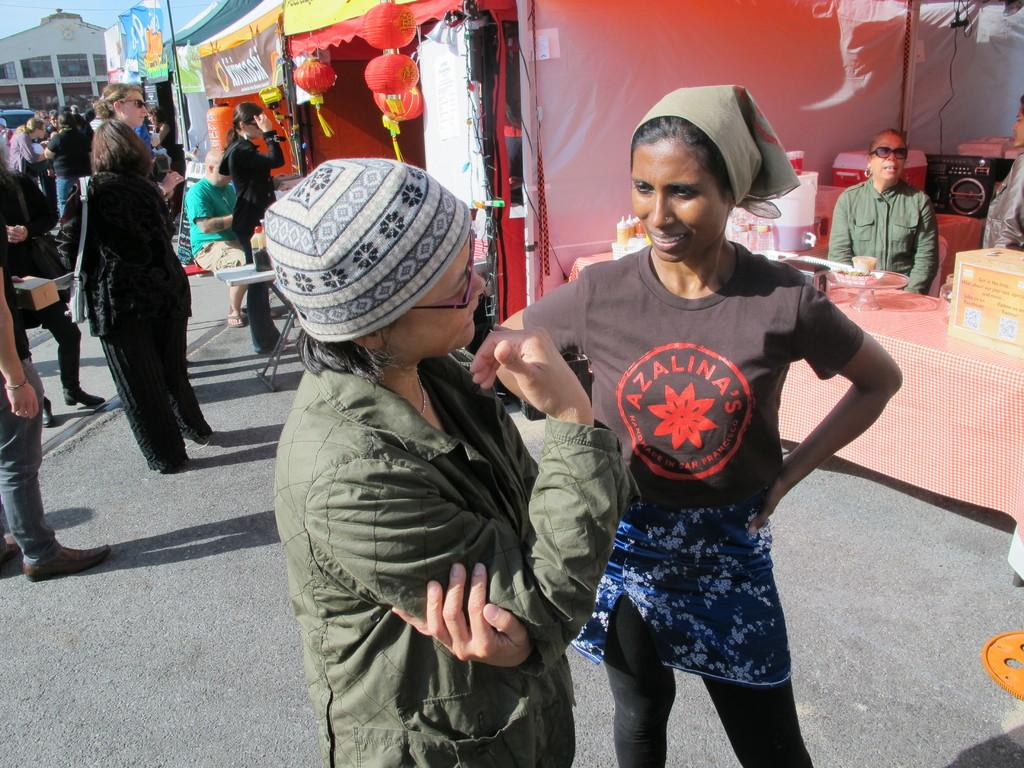What are the people in the image doing? The people in the image are standing on the ground. What type of furniture can be seen in the image? There are tables in the image. What decorative items are present in the image? Banners and lanterns are visible in the image. What type of containers are in the image? Boxes are in the image. What kind of device is present in the image? A device is present in the image. What else can be seen in the image? There are other objects in the image. What is visible in the background of the image? There is a building and the sky in the background of the image. What type of iron is being used to treat the cough in the image? There is no iron or cough treatment present in the image. What facial expression do the people in the image have? The provided facts do not mention the facial expressions of the people in the image. 